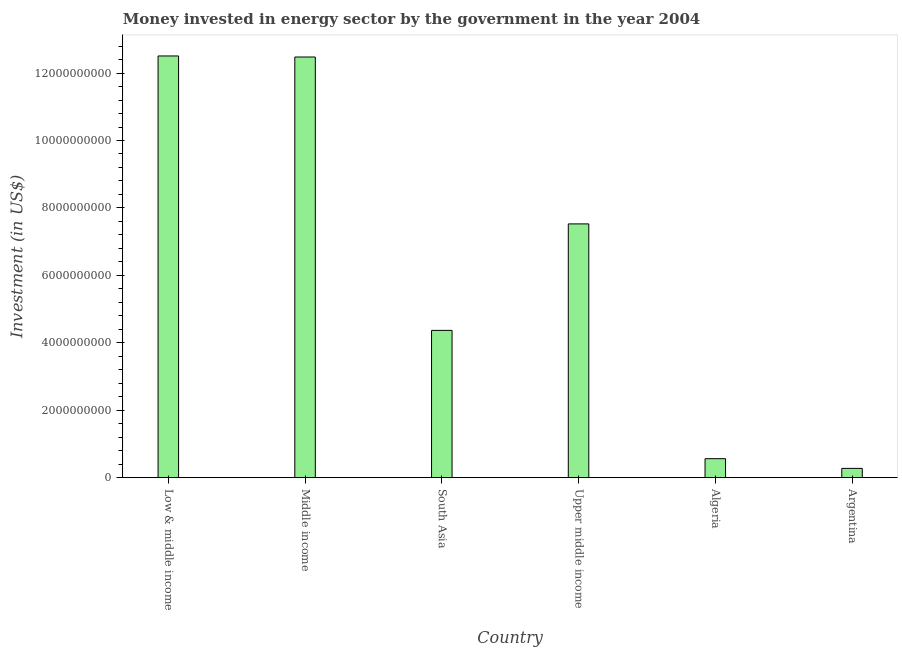Does the graph contain any zero values?
Offer a terse response. No. What is the title of the graph?
Give a very brief answer. Money invested in energy sector by the government in the year 2004. What is the label or title of the Y-axis?
Provide a short and direct response. Investment (in US$). What is the investment in energy in South Asia?
Provide a succinct answer. 4.37e+09. Across all countries, what is the maximum investment in energy?
Give a very brief answer. 1.25e+1. Across all countries, what is the minimum investment in energy?
Offer a very short reply. 2.74e+08. What is the sum of the investment in energy?
Your answer should be very brief. 3.77e+1. What is the difference between the investment in energy in Algeria and Middle income?
Make the answer very short. -1.19e+1. What is the average investment in energy per country?
Provide a short and direct response. 6.29e+09. What is the median investment in energy?
Make the answer very short. 5.95e+09. In how many countries, is the investment in energy greater than 9200000000 US$?
Your response must be concise. 2. What is the ratio of the investment in energy in Argentina to that in Middle income?
Your response must be concise. 0.02. Is the difference between the investment in energy in Algeria and Middle income greater than the difference between any two countries?
Offer a terse response. No. What is the difference between the highest and the second highest investment in energy?
Your answer should be very brief. 3.13e+07. Is the sum of the investment in energy in South Asia and Upper middle income greater than the maximum investment in energy across all countries?
Ensure brevity in your answer.  No. What is the difference between the highest and the lowest investment in energy?
Offer a very short reply. 1.22e+1. In how many countries, is the investment in energy greater than the average investment in energy taken over all countries?
Keep it short and to the point. 3. What is the difference between two consecutive major ticks on the Y-axis?
Keep it short and to the point. 2.00e+09. Are the values on the major ticks of Y-axis written in scientific E-notation?
Your answer should be very brief. No. What is the Investment (in US$) of Low & middle income?
Offer a very short reply. 1.25e+1. What is the Investment (in US$) of Middle income?
Your answer should be very brief. 1.25e+1. What is the Investment (in US$) in South Asia?
Provide a succinct answer. 4.37e+09. What is the Investment (in US$) in Upper middle income?
Ensure brevity in your answer.  7.53e+09. What is the Investment (in US$) of Algeria?
Your answer should be compact. 5.62e+08. What is the Investment (in US$) in Argentina?
Provide a succinct answer. 2.74e+08. What is the difference between the Investment (in US$) in Low & middle income and Middle income?
Offer a very short reply. 3.13e+07. What is the difference between the Investment (in US$) in Low & middle income and South Asia?
Your response must be concise. 8.14e+09. What is the difference between the Investment (in US$) in Low & middle income and Upper middle income?
Provide a succinct answer. 4.98e+09. What is the difference between the Investment (in US$) in Low & middle income and Algeria?
Give a very brief answer. 1.19e+1. What is the difference between the Investment (in US$) in Low & middle income and Argentina?
Provide a short and direct response. 1.22e+1. What is the difference between the Investment (in US$) in Middle income and South Asia?
Your response must be concise. 8.11e+09. What is the difference between the Investment (in US$) in Middle income and Upper middle income?
Provide a short and direct response. 4.95e+09. What is the difference between the Investment (in US$) in Middle income and Algeria?
Ensure brevity in your answer.  1.19e+1. What is the difference between the Investment (in US$) in Middle income and Argentina?
Your response must be concise. 1.22e+1. What is the difference between the Investment (in US$) in South Asia and Upper middle income?
Provide a succinct answer. -3.16e+09. What is the difference between the Investment (in US$) in South Asia and Algeria?
Your answer should be very brief. 3.81e+09. What is the difference between the Investment (in US$) in South Asia and Argentina?
Your response must be concise. 4.09e+09. What is the difference between the Investment (in US$) in Upper middle income and Algeria?
Offer a very short reply. 6.96e+09. What is the difference between the Investment (in US$) in Upper middle income and Argentina?
Provide a succinct answer. 7.25e+09. What is the difference between the Investment (in US$) in Algeria and Argentina?
Keep it short and to the point. 2.88e+08. What is the ratio of the Investment (in US$) in Low & middle income to that in Middle income?
Offer a very short reply. 1. What is the ratio of the Investment (in US$) in Low & middle income to that in South Asia?
Provide a succinct answer. 2.86. What is the ratio of the Investment (in US$) in Low & middle income to that in Upper middle income?
Give a very brief answer. 1.66. What is the ratio of the Investment (in US$) in Low & middle income to that in Algeria?
Offer a terse response. 22.25. What is the ratio of the Investment (in US$) in Low & middle income to that in Argentina?
Your answer should be very brief. 45.65. What is the ratio of the Investment (in US$) in Middle income to that in South Asia?
Provide a short and direct response. 2.86. What is the ratio of the Investment (in US$) in Middle income to that in Upper middle income?
Ensure brevity in your answer.  1.66. What is the ratio of the Investment (in US$) in Middle income to that in Argentina?
Make the answer very short. 45.53. What is the ratio of the Investment (in US$) in South Asia to that in Upper middle income?
Keep it short and to the point. 0.58. What is the ratio of the Investment (in US$) in South Asia to that in Algeria?
Your response must be concise. 7.77. What is the ratio of the Investment (in US$) in South Asia to that in Argentina?
Give a very brief answer. 15.94. What is the ratio of the Investment (in US$) in Upper middle income to that in Algeria?
Provide a succinct answer. 13.39. What is the ratio of the Investment (in US$) in Upper middle income to that in Argentina?
Your answer should be very brief. 27.47. What is the ratio of the Investment (in US$) in Algeria to that in Argentina?
Offer a terse response. 2.05. 